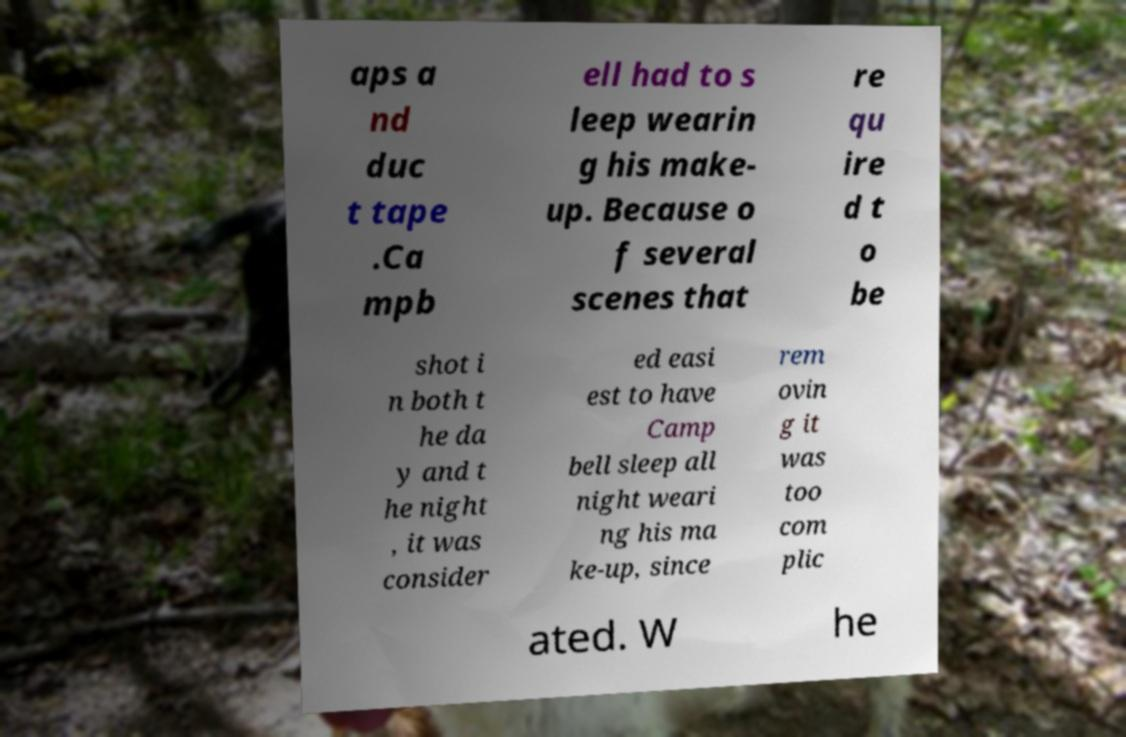For documentation purposes, I need the text within this image transcribed. Could you provide that? aps a nd duc t tape .Ca mpb ell had to s leep wearin g his make- up. Because o f several scenes that re qu ire d t o be shot i n both t he da y and t he night , it was consider ed easi est to have Camp bell sleep all night weari ng his ma ke-up, since rem ovin g it was too com plic ated. W he 